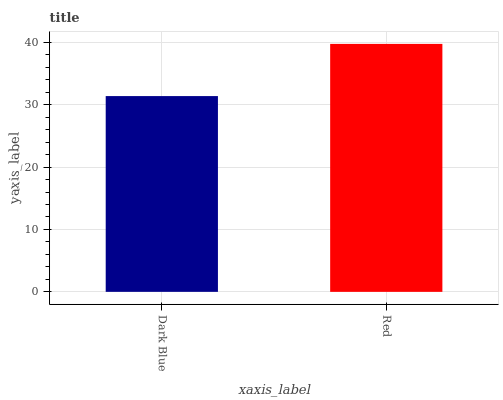Is Dark Blue the minimum?
Answer yes or no. Yes. Is Red the maximum?
Answer yes or no. Yes. Is Red the minimum?
Answer yes or no. No. Is Red greater than Dark Blue?
Answer yes or no. Yes. Is Dark Blue less than Red?
Answer yes or no. Yes. Is Dark Blue greater than Red?
Answer yes or no. No. Is Red less than Dark Blue?
Answer yes or no. No. Is Red the high median?
Answer yes or no. Yes. Is Dark Blue the low median?
Answer yes or no. Yes. Is Dark Blue the high median?
Answer yes or no. No. Is Red the low median?
Answer yes or no. No. 